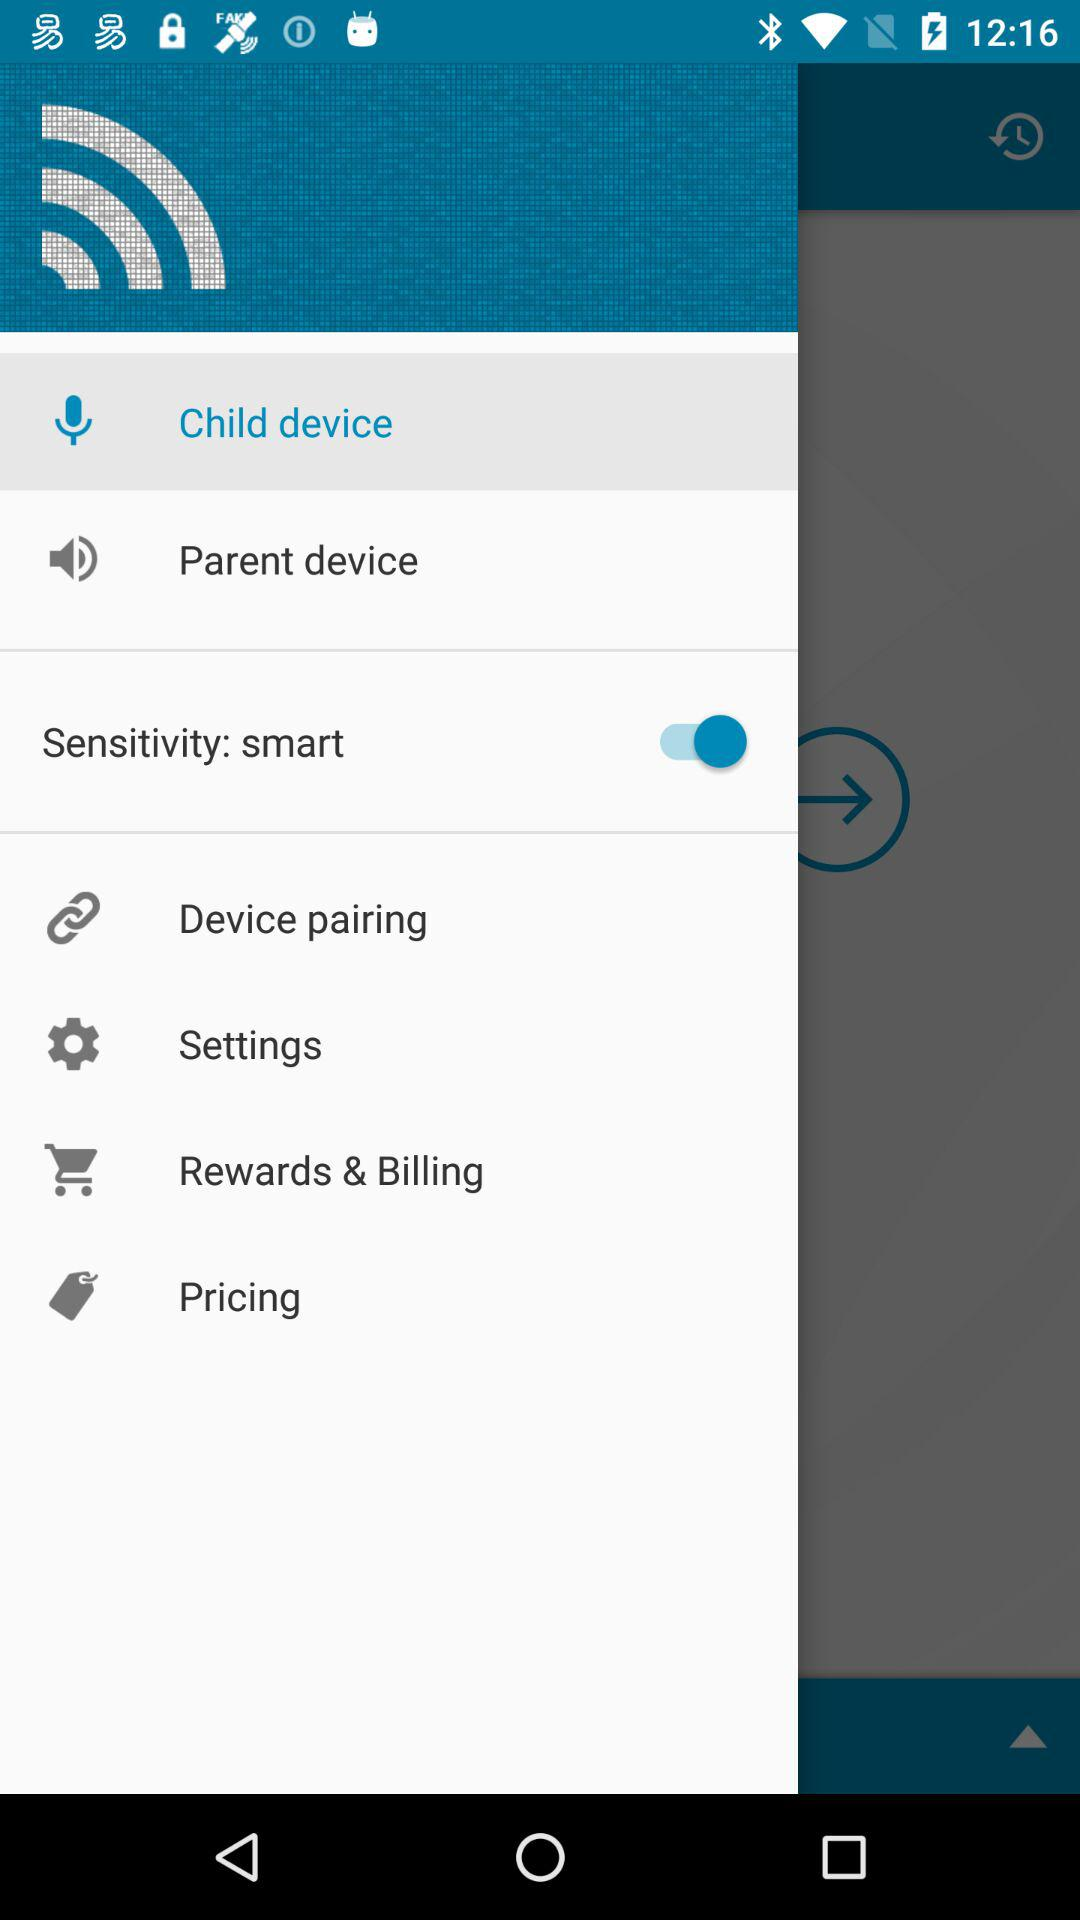Which tab has been selected? The tab that has been selected is "Child device". 